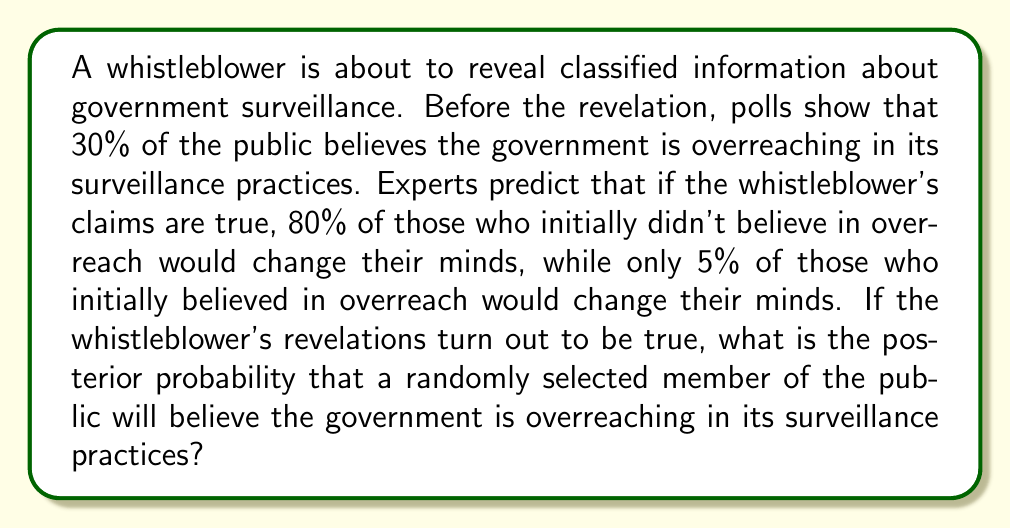Solve this math problem. Let's approach this problem using Bayes' theorem. We'll define the following events:

$O$: The event that a person believes the government is overreaching
$T$: The event that the whistleblower's claims are true

We're given the following probabilities:

1. $P(O) = 0.30$ (prior probability of believing in overreach)
2. $P(O|T) = 0.80 \cdot P(O^c) + 0.95 \cdot P(O)$ (probability of believing in overreach given the claims are true)

We want to find $P(O|T)$, the posterior probability of believing in overreach given that the claims are true.

Step 1: Calculate $P(O^c)$, the probability of not initially believing in overreach.
$P(O^c) = 1 - P(O) = 1 - 0.30 = 0.70$

Step 2: Calculate $P(O|T)$ using the given information.
$P(O|T) = 0.80 \cdot P(O^c) + 0.95 \cdot P(O)$
$P(O|T) = 0.80 \cdot 0.70 + 0.95 \cdot 0.30$
$P(O|T) = 0.56 + 0.285 = 0.845$

Therefore, the posterior probability that a randomly selected member of the public will believe the government is overreaching in its surveillance practices, given that the whistleblower's claims are true, is 0.845 or 84.5%.
Answer: $P(O|T) = 0.845$ or $84.5\%$ 